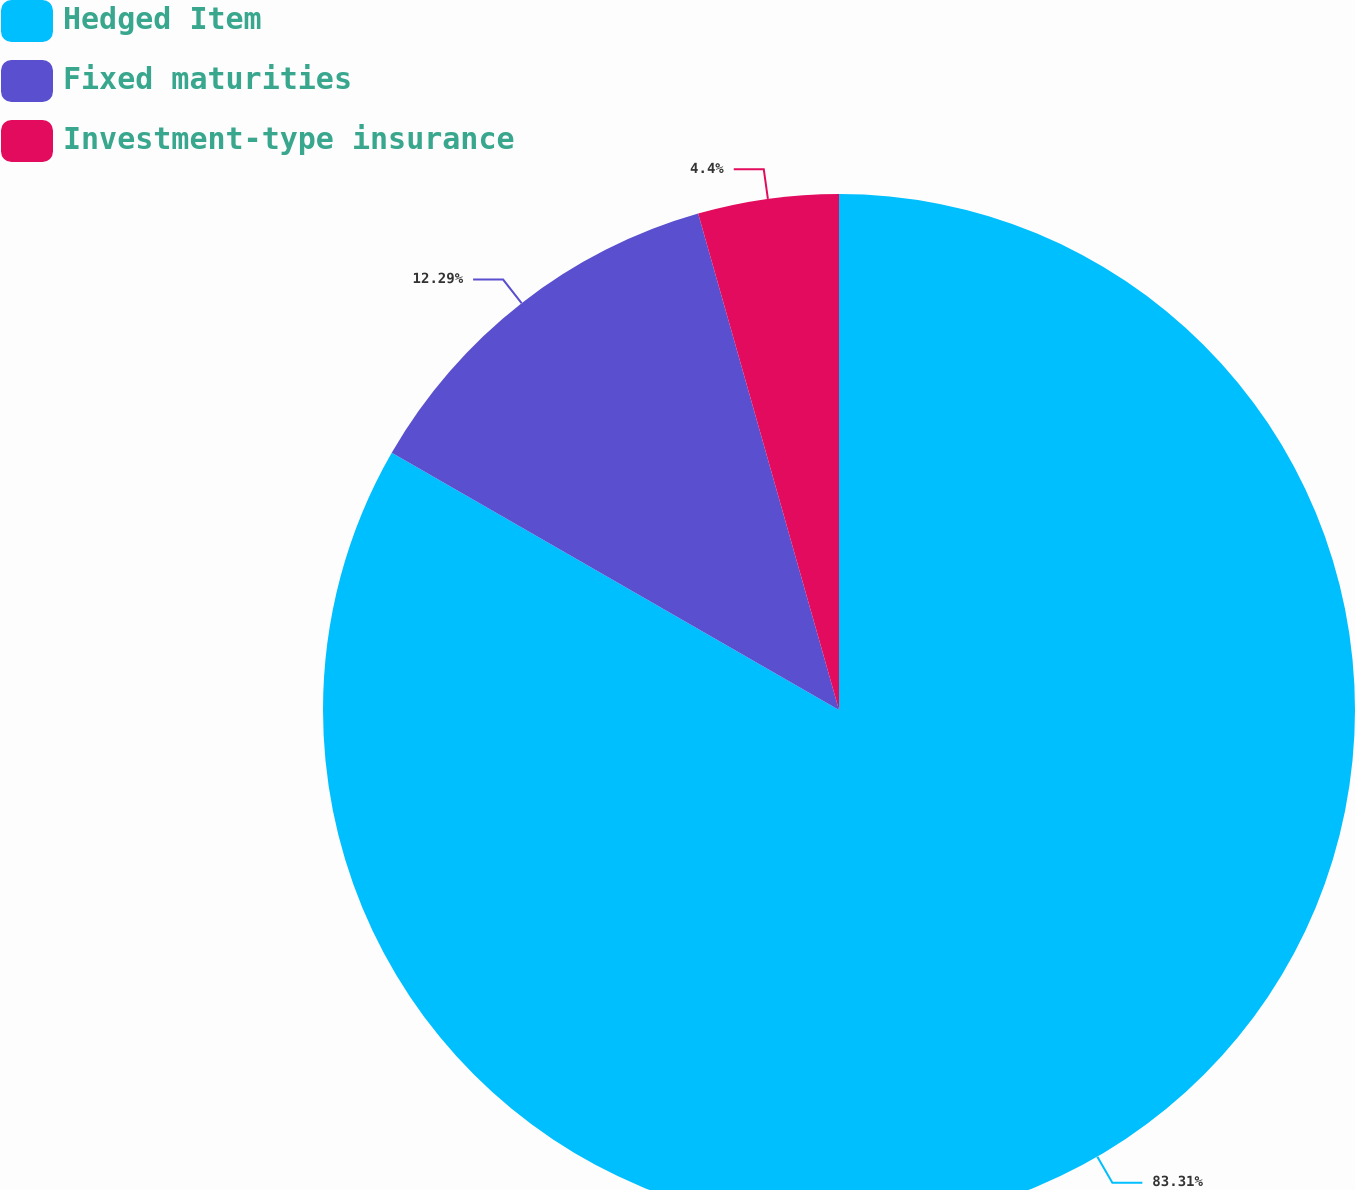Convert chart to OTSL. <chart><loc_0><loc_0><loc_500><loc_500><pie_chart><fcel>Hedged Item<fcel>Fixed maturities<fcel>Investment-type insurance<nl><fcel>83.3%<fcel>12.29%<fcel>4.4%<nl></chart> 